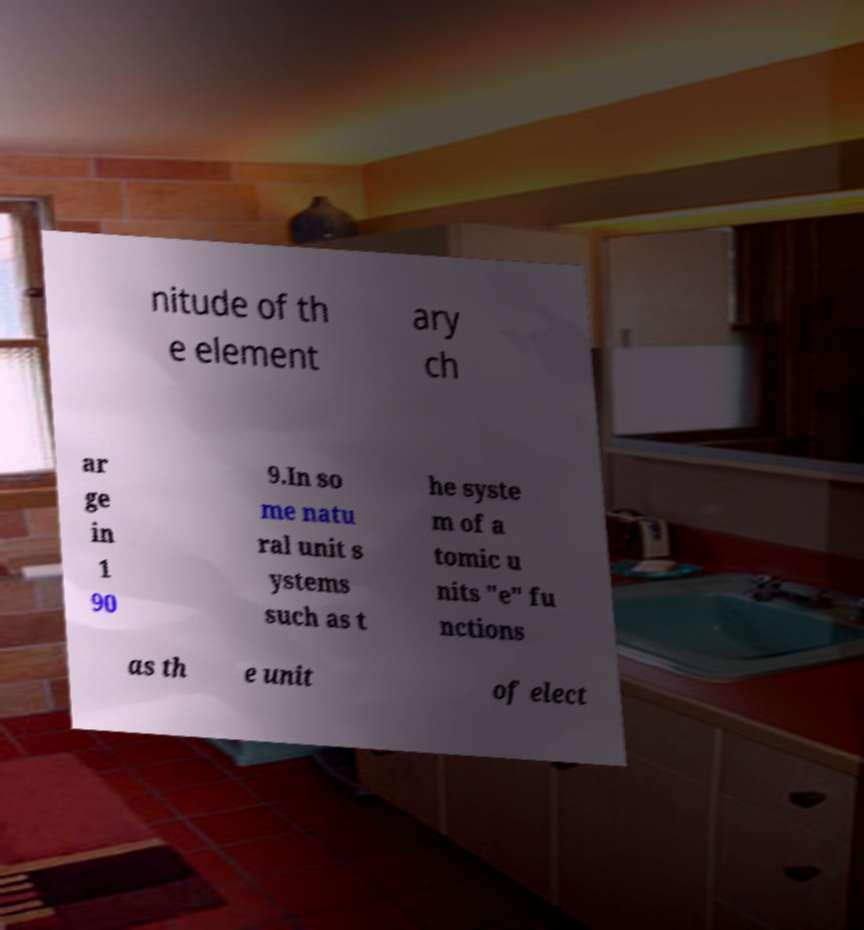Can you read and provide the text displayed in the image?This photo seems to have some interesting text. Can you extract and type it out for me? nitude of th e element ary ch ar ge in 1 90 9.In so me natu ral unit s ystems such as t he syste m of a tomic u nits "e" fu nctions as th e unit of elect 